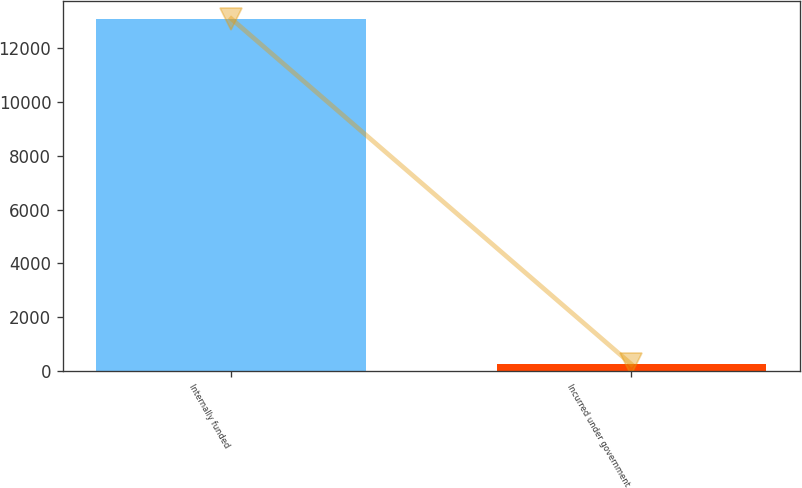Convert chart. <chart><loc_0><loc_0><loc_500><loc_500><bar_chart><fcel>Internally funded<fcel>Incurred under government<nl><fcel>13100<fcel>250<nl></chart> 